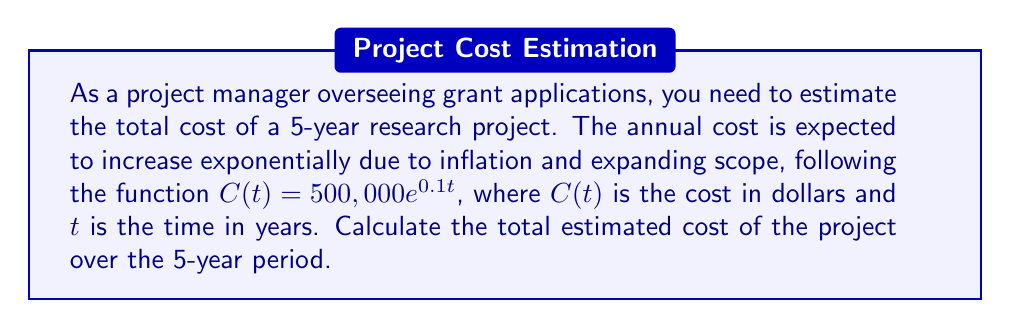Provide a solution to this math problem. To estimate the total cost of the project over the 5-year period, we need to integrate the cost function $C(t)$ from $t=0$ to $t=5$. This will give us the area under the curve, which represents the total cost.

Step 1: Set up the integral
$$\text{Total Cost} = \int_0^5 C(t) dt = \int_0^5 500,000e^{0.1t} dt$$

Step 2: Integrate the function
$$\begin{align*}
\text{Total Cost} &= 500,000 \int_0^5 e^{0.1t} dt \\
&= 500,000 \cdot \frac{1}{0.1} e^{0.1t} \Big|_0^5 \\
&= 5,000,000 \cdot (e^{0.5} - 1)
\end{align*}$$

Step 3: Evaluate the expression
$$\begin{align*}
\text{Total Cost} &= 5,000,000 \cdot (e^{0.5} - 1) \\
&\approx 5,000,000 \cdot (1.6487 - 1) \\
&\approx 5,000,000 \cdot 0.6487 \\
&\approx 3,243,500
\end{align*}$$

Therefore, the total estimated cost of the project over the 5-year period is approximately $3,243,500.
Answer: $3,243,500 